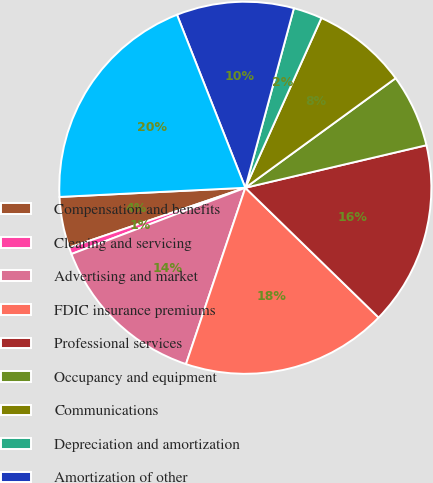Convert chart to OTSL. <chart><loc_0><loc_0><loc_500><loc_500><pie_chart><fcel>Compensation and benefits<fcel>Clearing and servicing<fcel>Advertising and market<fcel>FDIC insurance premiums<fcel>Professional services<fcel>Occupancy and equipment<fcel>Communications<fcel>Depreciation and amortization<fcel>Amortization of other<fcel>Other operating expenses<nl><fcel>4.43%<fcel>0.58%<fcel>14.04%<fcel>17.88%<fcel>15.96%<fcel>6.35%<fcel>8.27%<fcel>2.5%<fcel>10.19%<fcel>19.8%<nl></chart> 